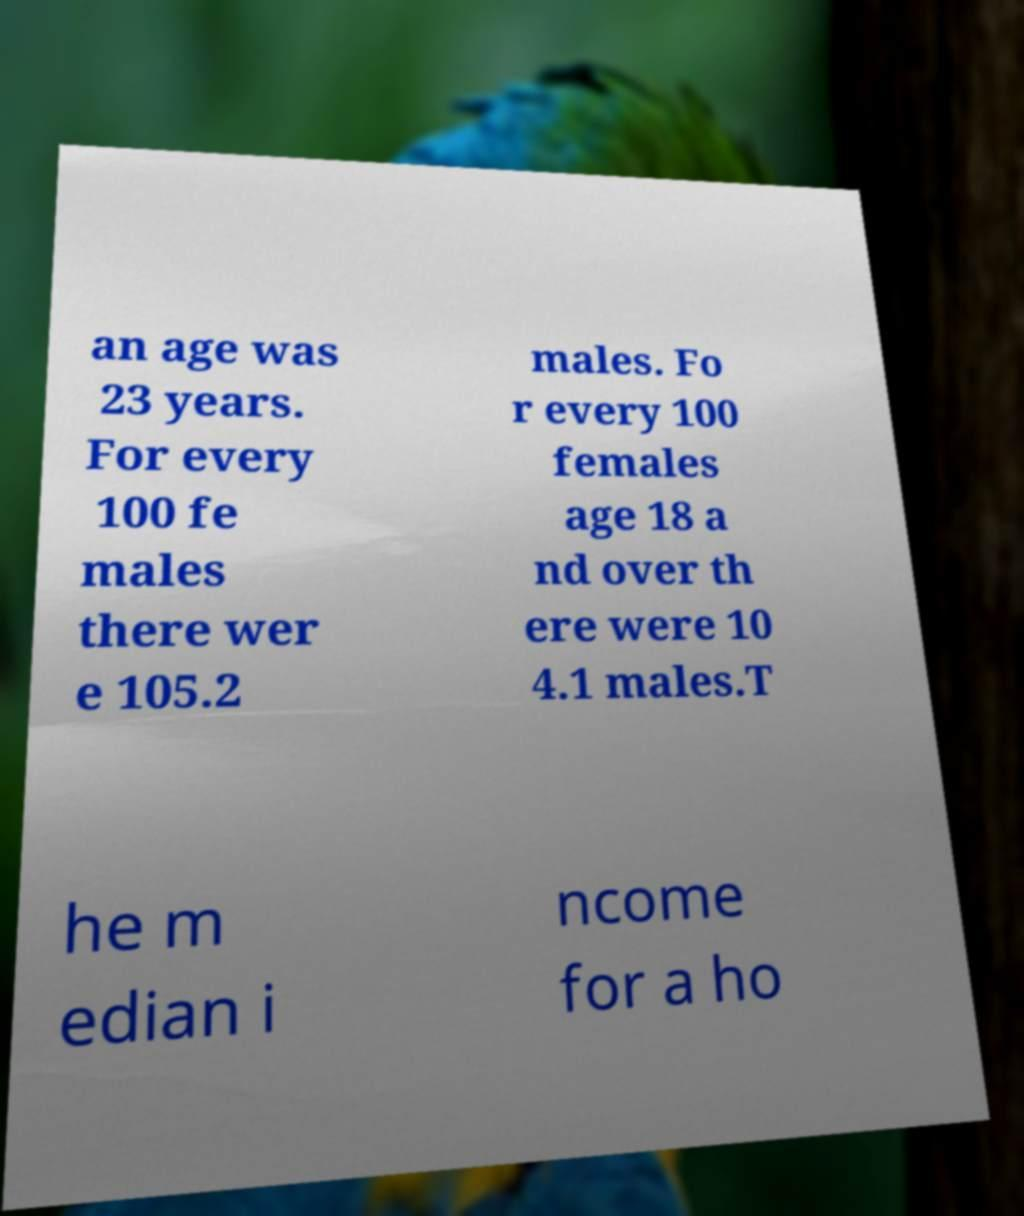Please read and relay the text visible in this image. What does it say? an age was 23 years. For every 100 fe males there wer e 105.2 males. Fo r every 100 females age 18 a nd over th ere were 10 4.1 males.T he m edian i ncome for a ho 